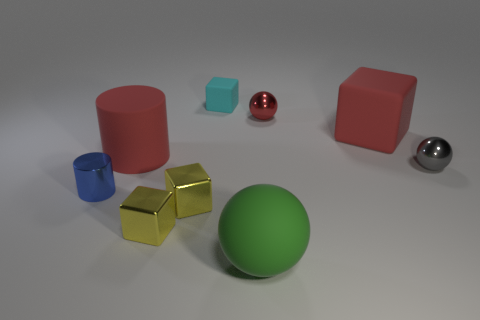Subtract all gray shiny spheres. How many spheres are left? 2 Subtract all gray balls. How many balls are left? 2 Subtract 4 cubes. How many cubes are left? 0 Subtract 0 purple cubes. How many objects are left? 9 Subtract all balls. How many objects are left? 6 Subtract all brown cubes. Subtract all green balls. How many cubes are left? 4 Subtract all blue cylinders. How many red blocks are left? 1 Subtract all small rubber objects. Subtract all big cyan shiny blocks. How many objects are left? 8 Add 1 tiny gray things. How many tiny gray things are left? 2 Add 4 big red cylinders. How many big red cylinders exist? 5 